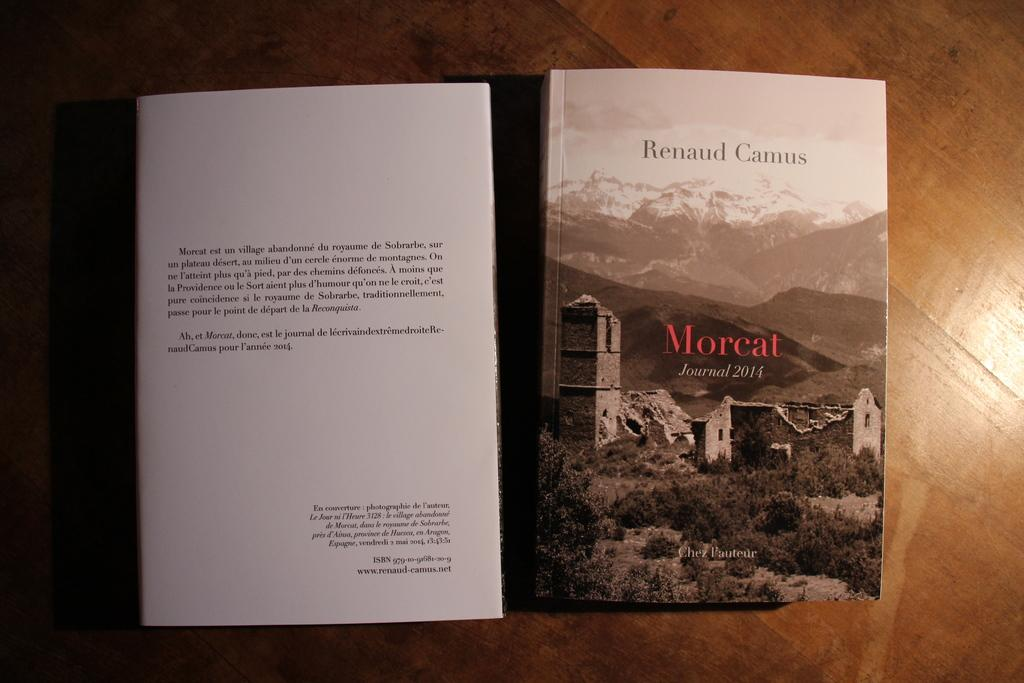<image>
Write a terse but informative summary of the picture. A book by Renaud Camus called Morcat Journal 2014 sits on a table. 